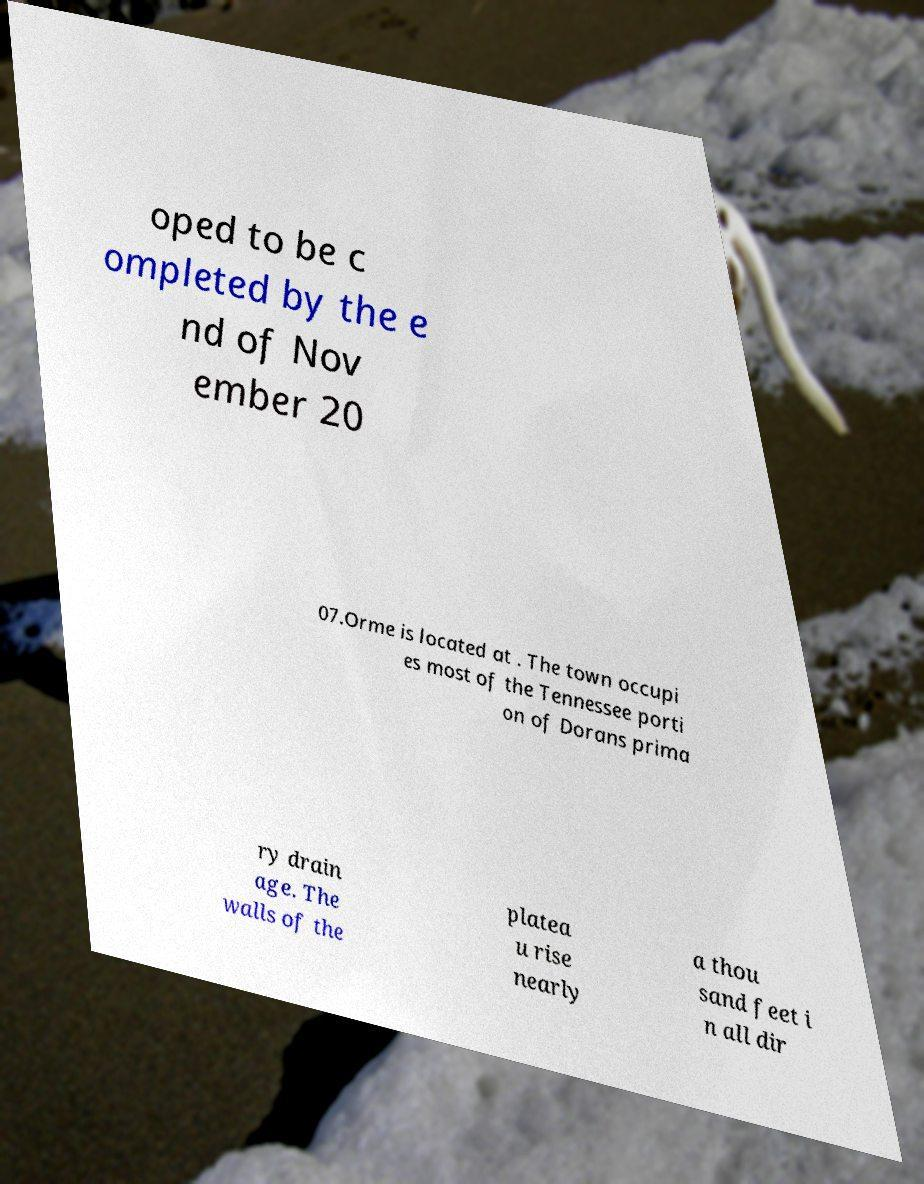Could you assist in decoding the text presented in this image and type it out clearly? oped to be c ompleted by the e nd of Nov ember 20 07.Orme is located at . The town occupi es most of the Tennessee porti on of Dorans prima ry drain age. The walls of the platea u rise nearly a thou sand feet i n all dir 